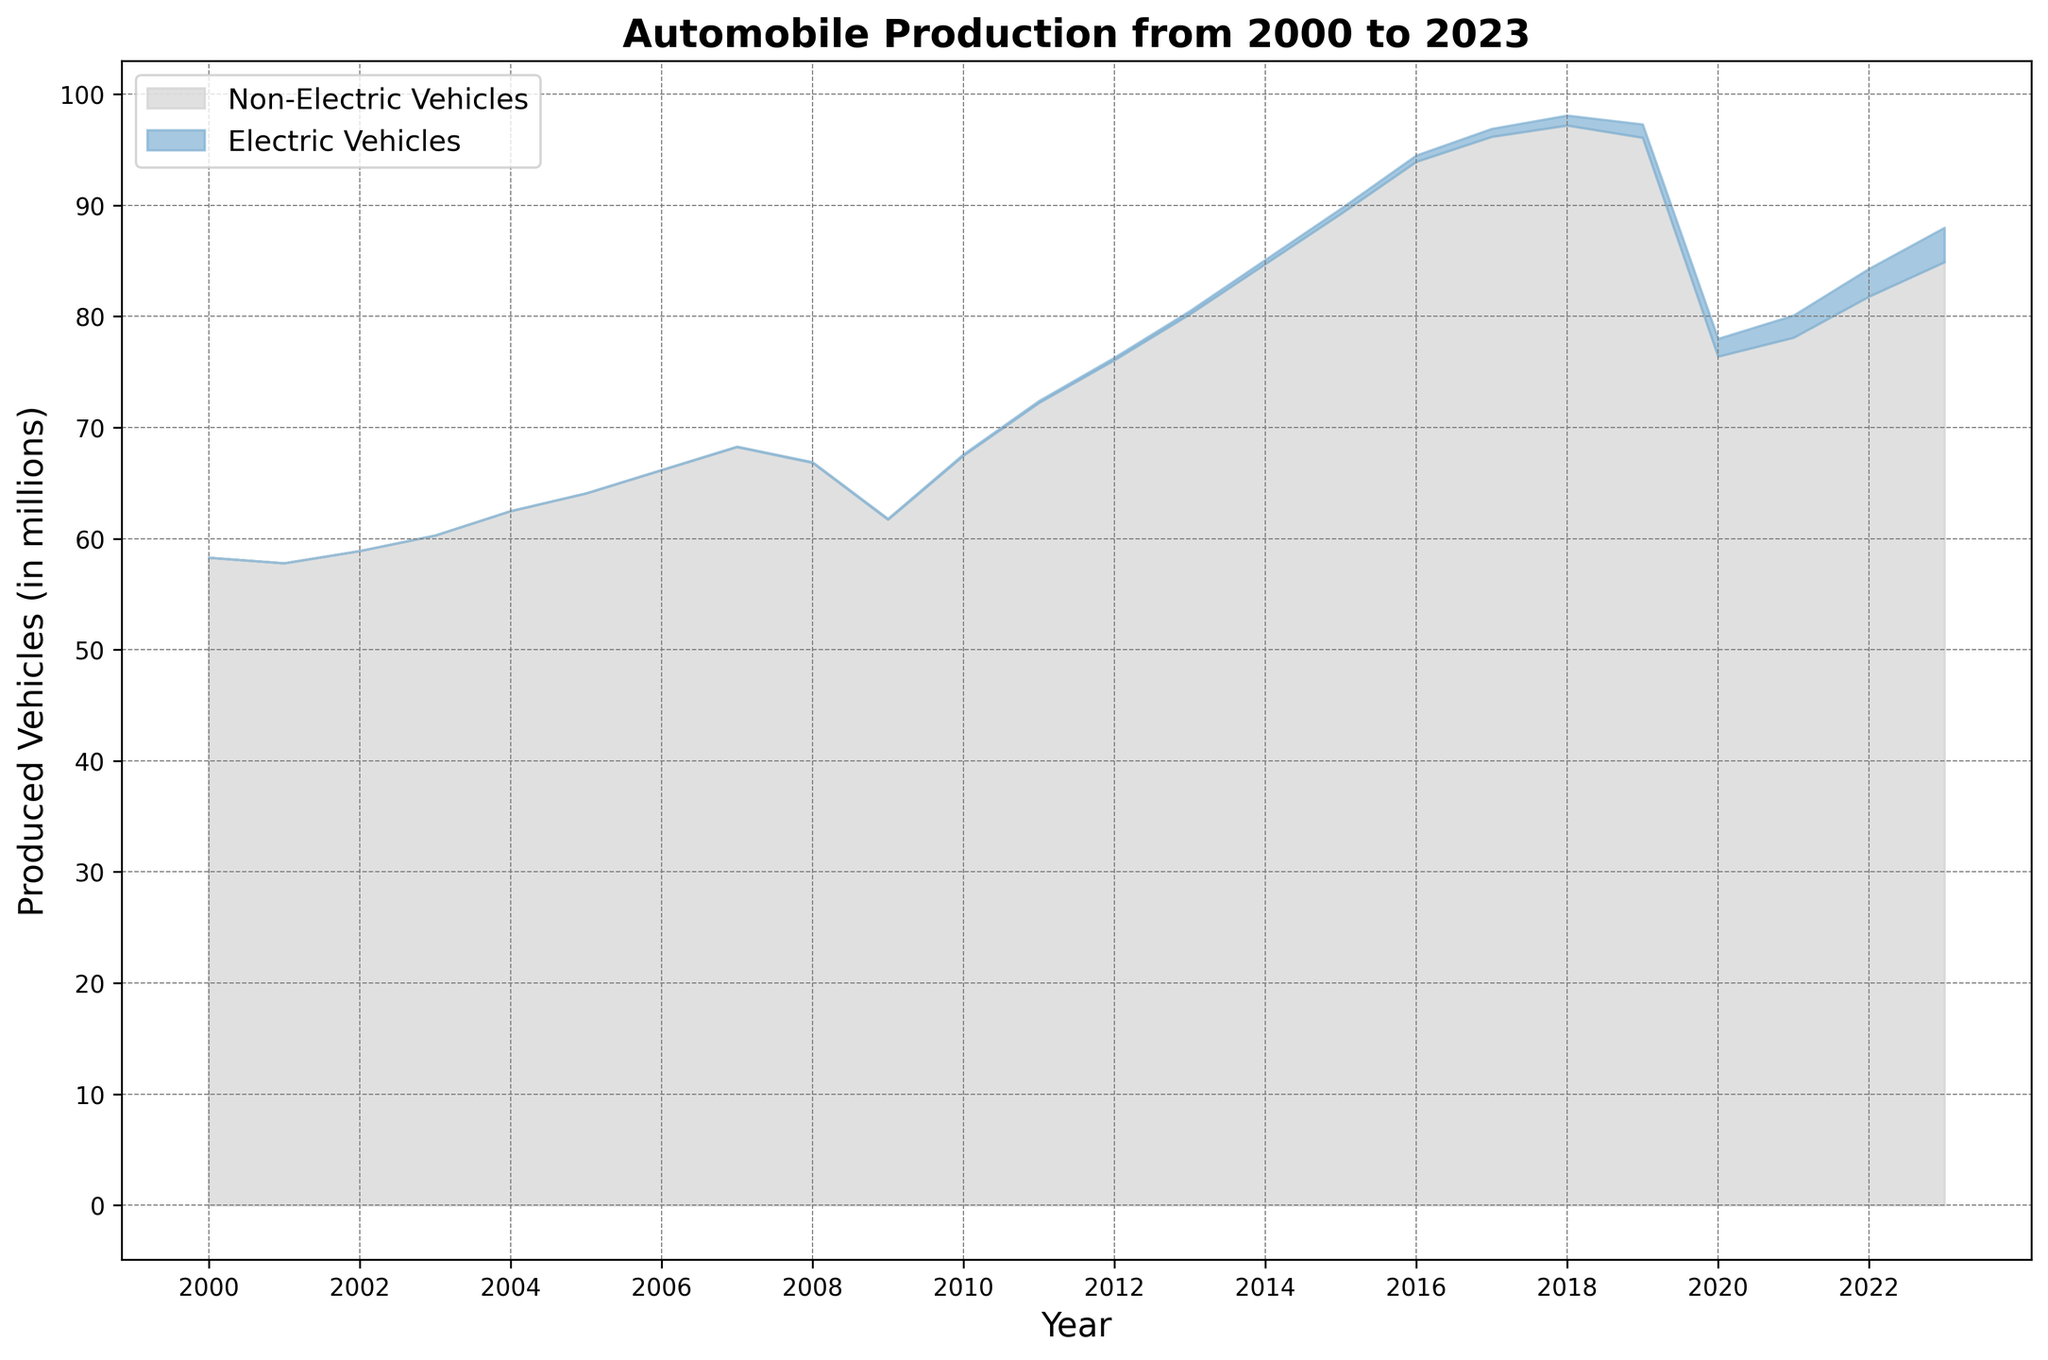What is the total number of electric vehicles produced in 2015? To find the total number of electric vehicles produced in 2015, refer to the data point specifically for electric vehicles in the year 2015 on the area chart.
Answer: 0.460 million What is the difference in the total number of automobiles produced between the year 2000 and 2020? Look at the y-axis values for the total number of automobiles produced for the years 2000 and 2020, then find the difference between these two values. In year 2000, it is 58.3 million and in year 2020, it is 78.0 million. So, the difference is 78.0 - 58.3.
Answer: 19.7 million How much did the production of electric vehicles increase from 2018 to 2023? Find the y-axis values for electric vehicles in 2018 and 2023. In 2018, the production is 0.900 million and in 2023, it is 3.100 million. Subtract the production of 2018 from 2023.
Answer: 2.200 million Which year had the highest total automobile production and what was the value? Scan the area chart for the peak point in the total automobile production curve. The year with the highest production is 2018, and the production value can be read from the corresponding y-axis.
Answer: 2018, 98.1 million Between which consecutive years did electric vehicle production see the greatest increase and how much was the increase? Compare the year-over-year increase in electric vehicle production by examining the difference in electric vehicle production between each pair of consecutive years. The greatest increase is between 2019 (1.200 million) and 2020 (1.600 million), which is 1.600 - 1.200.
Answer: 2019-2020, 0.400 million What is the color used to represent electric vehicles in the area chart? Visually inspect the area chart to determine the color fill specifically representing electric vehicles.
Answer: Light blue What was the approximate total number of electric vehicles produced from 2000 to 2023? Sum the values of electric vehicles produced for all the years from the data. Calculations: 0.002 + 0.004 + 0.007 + 0.012 + 0.018 + 0.025 + 0.035 + 0.047 + 0.060 + 0.080 + 0.120 + 0.170 + 0.220 + 0.290 + 0.370 + 0.460 + 0.570 + 0.720 + 0.900 + 1.200 + 1.600 + 2.000 + 2.500 + 3.100 = 17.510.
Answer: 17.510 million 